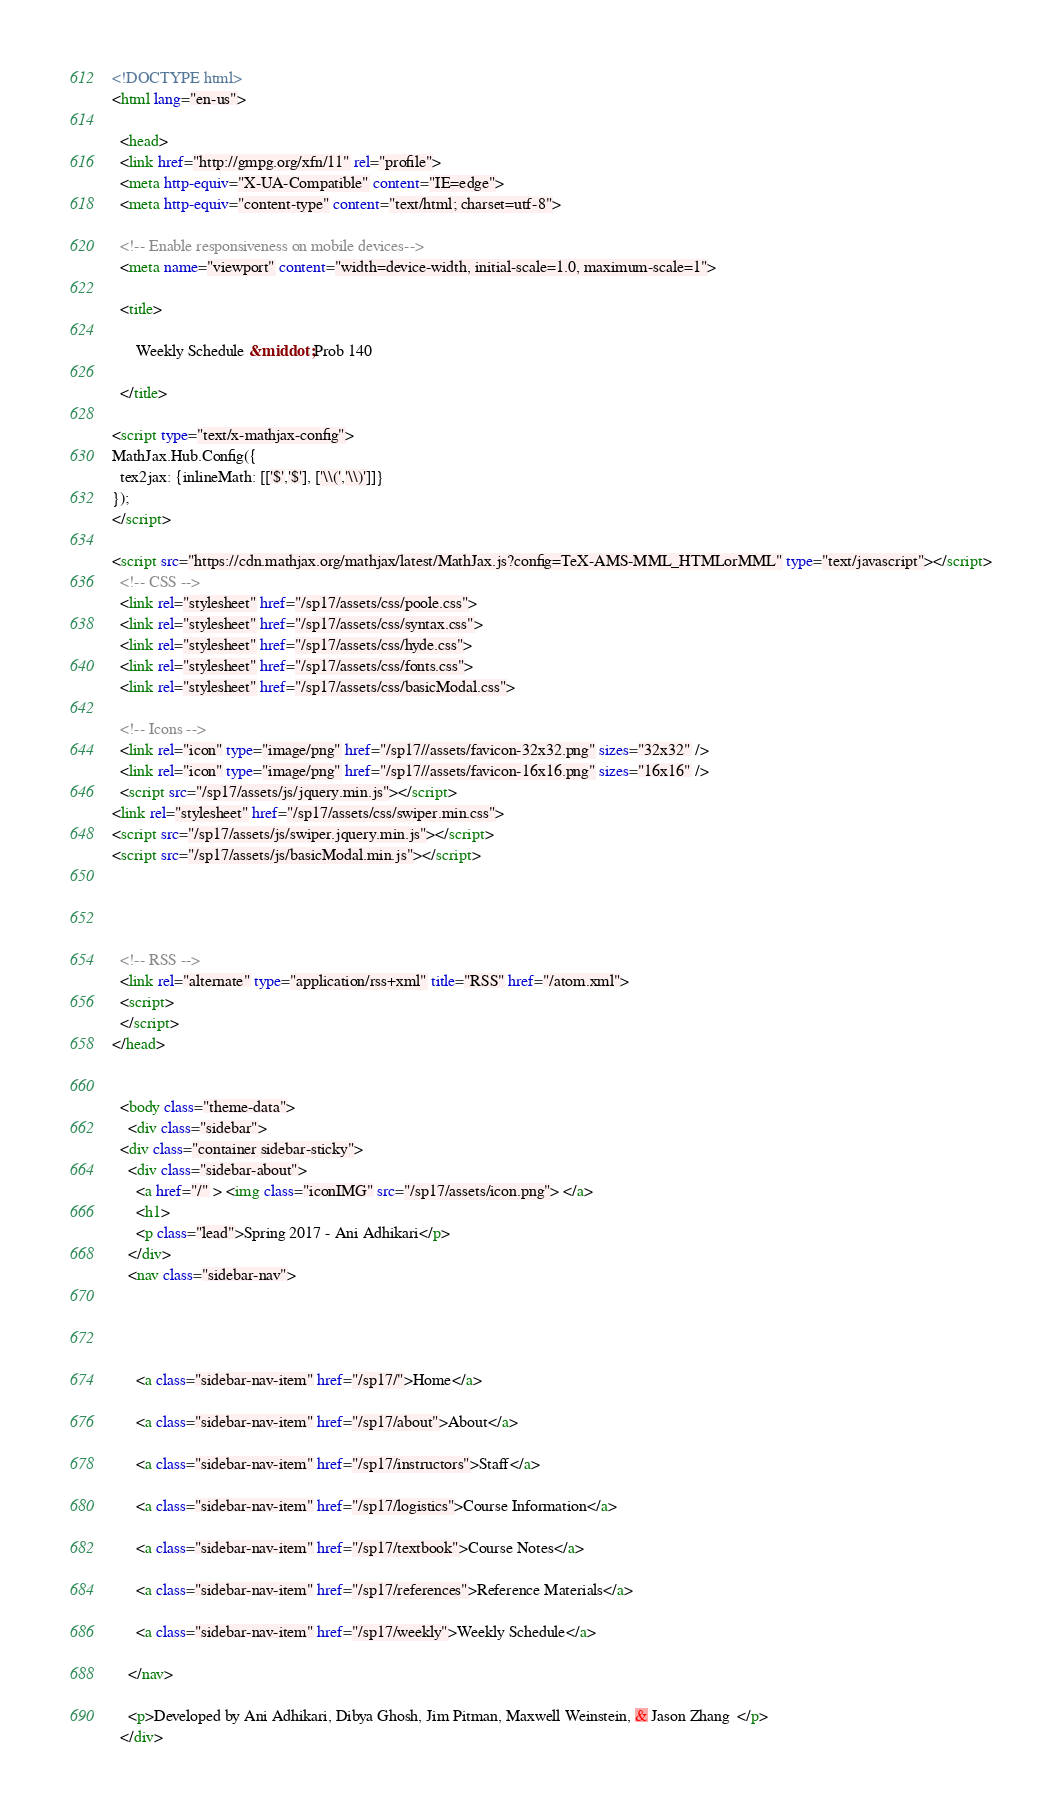Convert code to text. <code><loc_0><loc_0><loc_500><loc_500><_HTML_><!DOCTYPE html>
<html lang="en-us">

  <head>
  <link href="http://gmpg.org/xfn/11" rel="profile">
  <meta http-equiv="X-UA-Compatible" content="IE=edge">
  <meta http-equiv="content-type" content="text/html; charset=utf-8">

  <!-- Enable responsiveness on mobile devices-->
  <meta name="viewport" content="width=device-width, initial-scale=1.0, maximum-scale=1">

  <title>
    
      Weekly Schedule &middot; Prob 140
    
  </title>

<script type="text/x-mathjax-config">
MathJax.Hub.Config({
  tex2jax: {inlineMath: [['$','$'], ['\\(','\\)']]}
});
</script>

<script src="https://cdn.mathjax.org/mathjax/latest/MathJax.js?config=TeX-AMS-MML_HTMLorMML" type="text/javascript"></script>
  <!-- CSS -->
  <link rel="stylesheet" href="/sp17/assets/css/poole.css">
  <link rel="stylesheet" href="/sp17/assets/css/syntax.css">
  <link rel="stylesheet" href="/sp17/assets/css/hyde.css">
  <link rel="stylesheet" href="/sp17/assets/css/fonts.css">
  <link rel="stylesheet" href="/sp17/assets/css/basicModal.css">

  <!-- Icons -->
  <link rel="icon" type="image/png" href="/sp17//assets/favicon-32x32.png" sizes="32x32" />
  <link rel="icon" type="image/png" href="/sp17//assets/favicon-16x16.png" sizes="16x16" />
  <script src="/sp17/assets/js/jquery.min.js"></script>
<link rel="stylesheet" href="/sp17/assets/css/swiper.min.css">
<script src="/sp17/assets/js/swiper.jquery.min.js"></script>
<script src="/sp17/assets/js/basicModal.min.js"></script>




  <!-- RSS -->
  <link rel="alternate" type="application/rss+xml" title="RSS" href="/atom.xml">
  <script>
  </script>
</head>


  <body class="theme-data">
    <div class="sidebar">
  <div class="container sidebar-sticky">
    <div class="sidebar-about">
      <a href="/" > <img class="iconIMG" src="/sp17/assets/icon.png"> </a>
      <h1>
      <p class="lead">Spring 2017 - Ani Adhikari</p>
    </div>
    <nav class="sidebar-nav">

      
      
      
      <a class="sidebar-nav-item" href="/sp17/">Home</a>
      
      <a class="sidebar-nav-item" href="/sp17/about">About</a>
      
      <a class="sidebar-nav-item" href="/sp17/instructors">Staff</a>
      
      <a class="sidebar-nav-item" href="/sp17/logistics">Course Information</a>
      
      <a class="sidebar-nav-item" href="/sp17/textbook">Course Notes</a>
      
      <a class="sidebar-nav-item" href="/sp17/references">Reference Materials</a>
      
      <a class="sidebar-nav-item" href="/sp17/weekly">Weekly Schedule</a>
      
    </nav>

    <p>Developed by Ani Adhikari, Dibya Ghosh, Jim Pitman, Maxwell Weinstein, & Jason Zhang  </p>
  </div></code> 